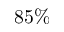<formula> <loc_0><loc_0><loc_500><loc_500>8 5 \%</formula> 